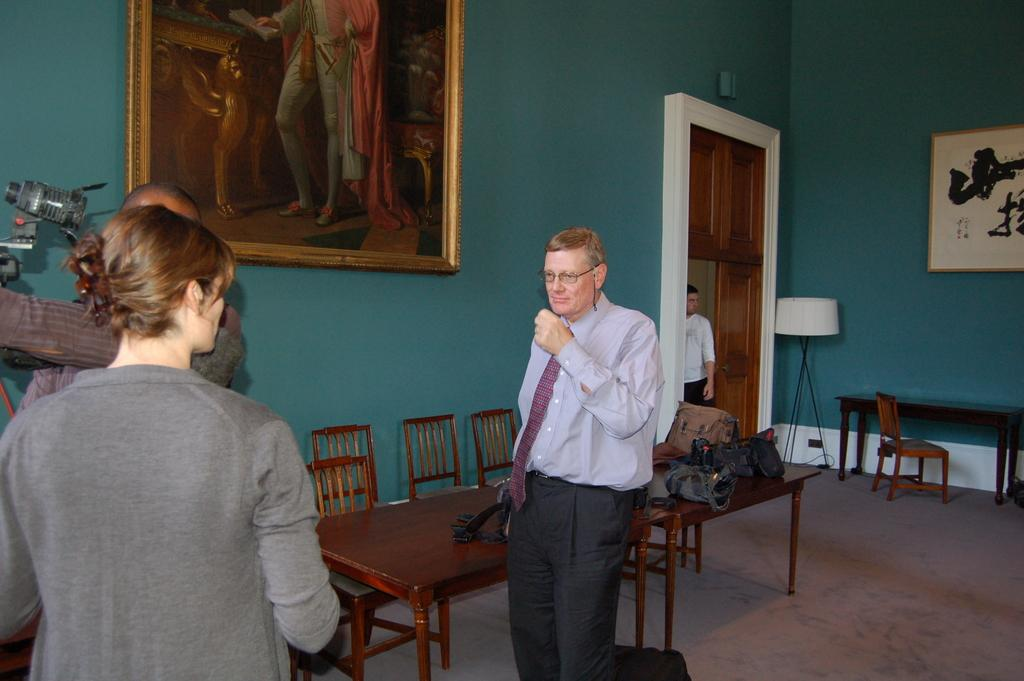What is happening in the room in the image? There are people standing in the room. What furniture is present in the room? The room has a table and chairs. What decorations are in the room? There are photos and posters in the room. What lighting is available in the room? There are table lamps in the room. What objects can be seen in the background? There are bags in the background. How would you describe the weather outside the room? The background is cloudy, suggesting an overcast or cloudy day. Can you tell me how many railway tracks are visible in the image? There are no railway tracks present in the image; it features a room with people, furniture, and decorations. What type of butter is being used to prepare the meal in the image? There is no meal or butter present in the image; it focuses on a room with people, furniture, and decorations. 